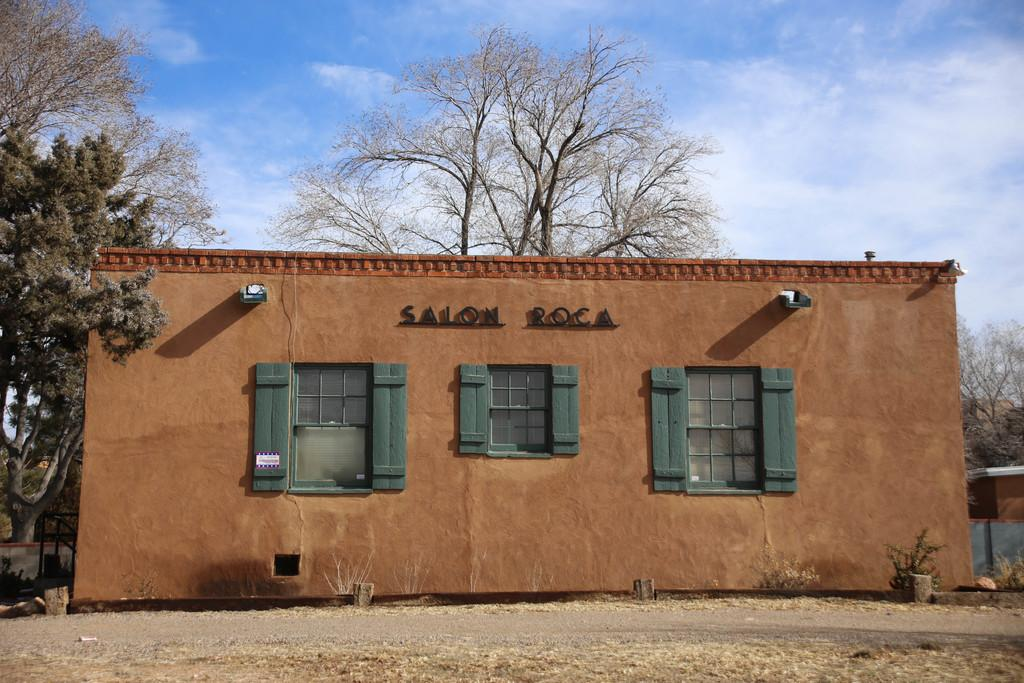What is the main subject of the image? The main subject of the image is a building. What specific features can be observed on the building? The building has windows. What can be seen in the background of the image? There are trees and the sky visible in the background of the image. What type of potato is being sold at the price displayed on the building? There is no potato or price displayed on the building in the image. What type of scissors can be seen cutting the branches of the trees in the background? There are no scissors or branches being cut in the image; it only features a building, trees, and the sky. 